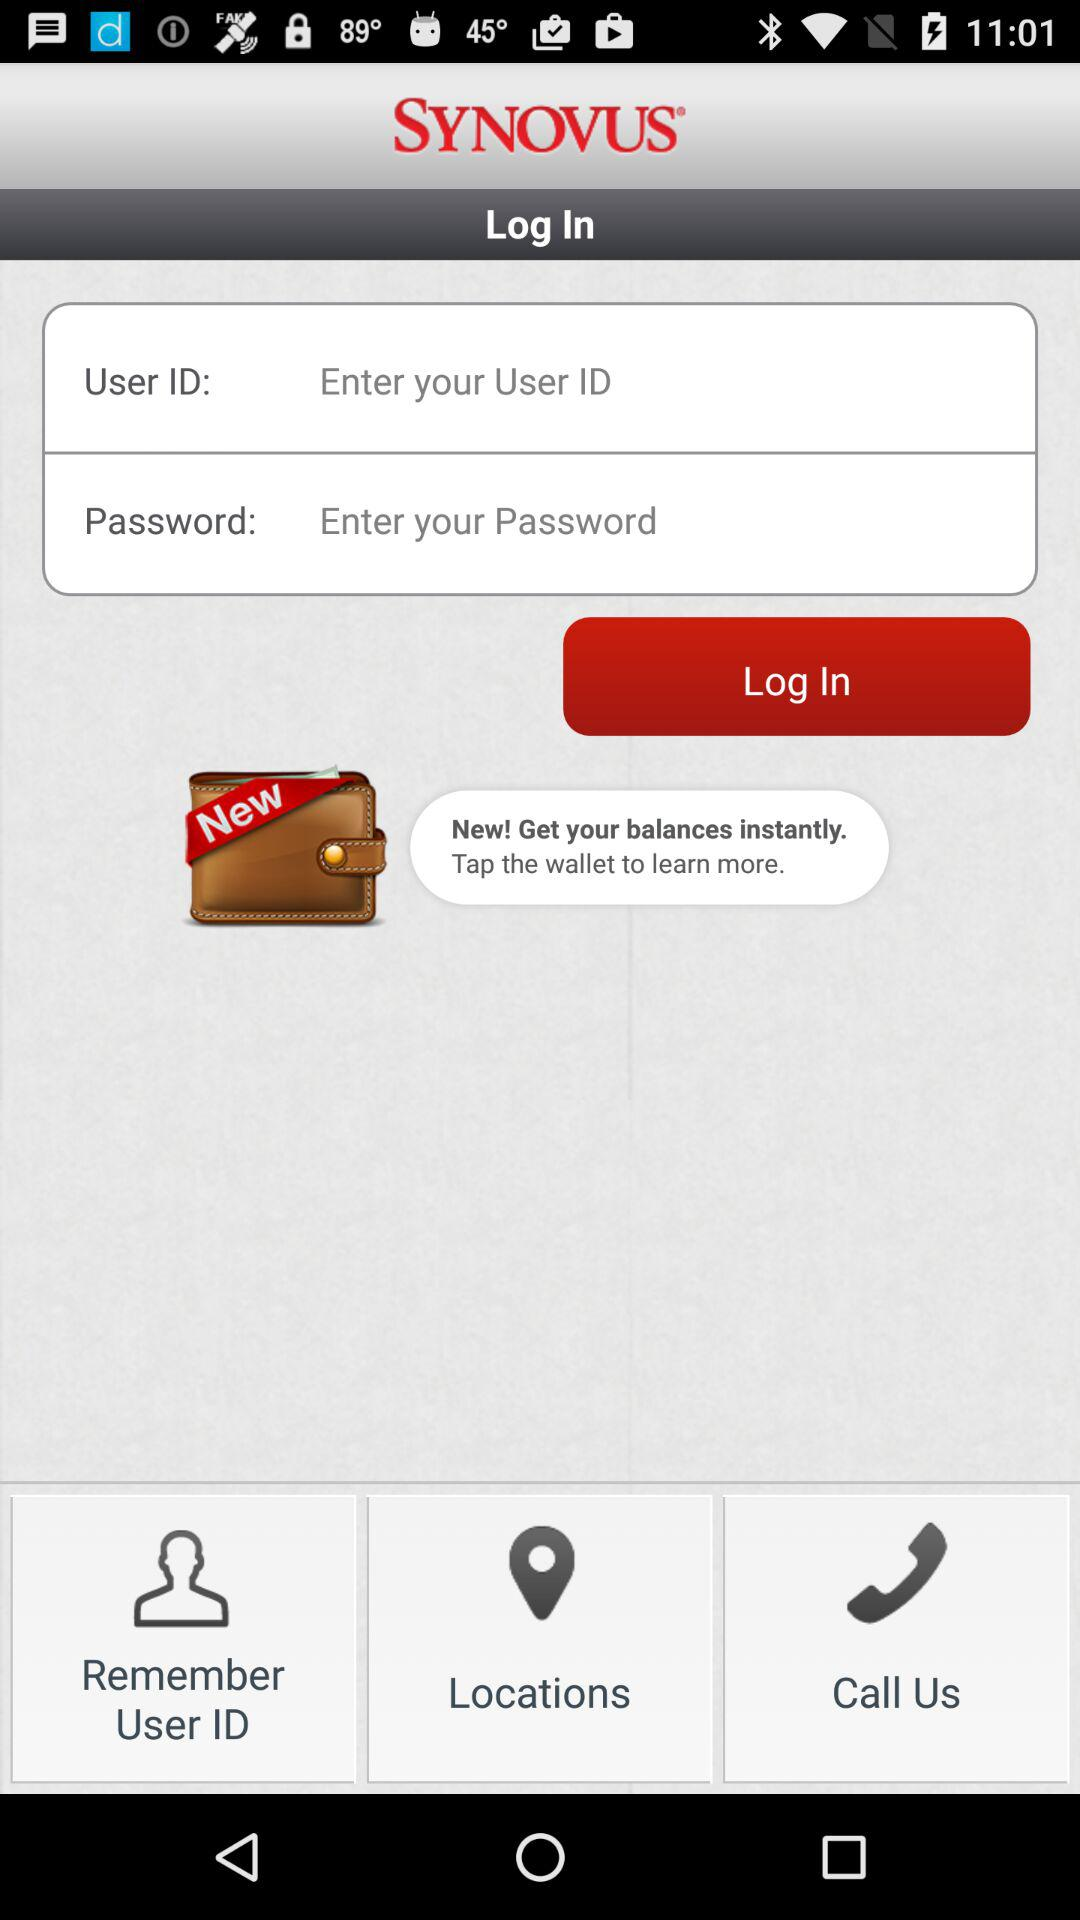How many login fields are there?
Answer the question using a single word or phrase. 2 